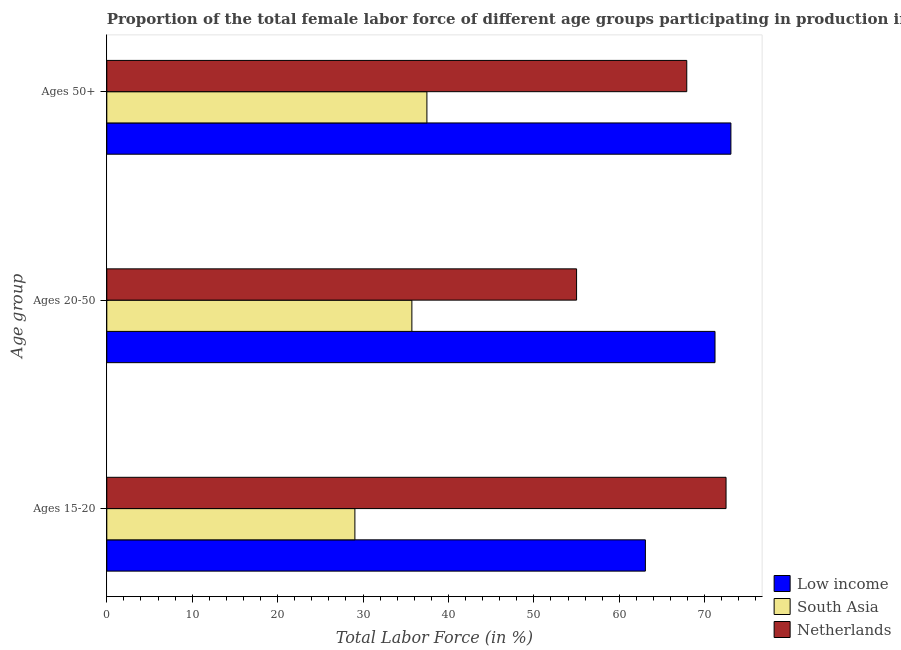How many groups of bars are there?
Ensure brevity in your answer.  3. Are the number of bars per tick equal to the number of legend labels?
Provide a short and direct response. Yes. How many bars are there on the 1st tick from the top?
Keep it short and to the point. 3. How many bars are there on the 2nd tick from the bottom?
Offer a terse response. 3. What is the label of the 2nd group of bars from the top?
Offer a terse response. Ages 20-50. What is the percentage of female labor force within the age group 20-50 in Low income?
Your answer should be very brief. 71.21. Across all countries, what is the maximum percentage of female labor force above age 50?
Give a very brief answer. 73.07. Across all countries, what is the minimum percentage of female labor force within the age group 20-50?
Make the answer very short. 35.72. In which country was the percentage of female labor force above age 50 maximum?
Ensure brevity in your answer.  Low income. In which country was the percentage of female labor force within the age group 20-50 minimum?
Your response must be concise. South Asia. What is the total percentage of female labor force within the age group 15-20 in the graph?
Ensure brevity in your answer.  164.6. What is the difference between the percentage of female labor force within the age group 15-20 in South Asia and that in Netherlands?
Your response must be concise. -43.45. What is the difference between the percentage of female labor force above age 50 in Netherlands and the percentage of female labor force within the age group 15-20 in Low income?
Your response must be concise. 4.84. What is the average percentage of female labor force within the age group 20-50 per country?
Your answer should be compact. 53.98. What is the difference between the percentage of female labor force within the age group 20-50 and percentage of female labor force within the age group 15-20 in South Asia?
Keep it short and to the point. 6.67. In how many countries, is the percentage of female labor force within the age group 20-50 greater than 50 %?
Offer a terse response. 2. What is the ratio of the percentage of female labor force within the age group 20-50 in Low income to that in Netherlands?
Your answer should be very brief. 1.29. Is the percentage of female labor force within the age group 20-50 in South Asia less than that in Low income?
Give a very brief answer. Yes. What is the difference between the highest and the second highest percentage of female labor force within the age group 20-50?
Keep it short and to the point. 16.21. What is the difference between the highest and the lowest percentage of female labor force within the age group 15-20?
Your response must be concise. 43.45. Is the sum of the percentage of female labor force above age 50 in Netherlands and South Asia greater than the maximum percentage of female labor force within the age group 15-20 across all countries?
Your answer should be compact. Yes. What does the 2nd bar from the top in Ages 20-50 represents?
Offer a terse response. South Asia. What does the 1st bar from the bottom in Ages 50+ represents?
Your response must be concise. Low income. Is it the case that in every country, the sum of the percentage of female labor force within the age group 15-20 and percentage of female labor force within the age group 20-50 is greater than the percentage of female labor force above age 50?
Your response must be concise. Yes. How many bars are there?
Give a very brief answer. 9. What is the title of the graph?
Offer a very short reply. Proportion of the total female labor force of different age groups participating in production in 2002. Does "Somalia" appear as one of the legend labels in the graph?
Offer a very short reply. No. What is the label or title of the X-axis?
Make the answer very short. Total Labor Force (in %). What is the label or title of the Y-axis?
Provide a short and direct response. Age group. What is the Total Labor Force (in %) in Low income in Ages 15-20?
Your answer should be very brief. 63.06. What is the Total Labor Force (in %) in South Asia in Ages 15-20?
Give a very brief answer. 29.05. What is the Total Labor Force (in %) in Netherlands in Ages 15-20?
Your response must be concise. 72.5. What is the Total Labor Force (in %) of Low income in Ages 20-50?
Your answer should be compact. 71.21. What is the Total Labor Force (in %) in South Asia in Ages 20-50?
Give a very brief answer. 35.72. What is the Total Labor Force (in %) of Low income in Ages 50+?
Make the answer very short. 73.07. What is the Total Labor Force (in %) in South Asia in Ages 50+?
Your response must be concise. 37.48. What is the Total Labor Force (in %) of Netherlands in Ages 50+?
Your answer should be very brief. 67.9. Across all Age group, what is the maximum Total Labor Force (in %) of Low income?
Keep it short and to the point. 73.07. Across all Age group, what is the maximum Total Labor Force (in %) in South Asia?
Your answer should be very brief. 37.48. Across all Age group, what is the maximum Total Labor Force (in %) of Netherlands?
Offer a very short reply. 72.5. Across all Age group, what is the minimum Total Labor Force (in %) of Low income?
Offer a very short reply. 63.06. Across all Age group, what is the minimum Total Labor Force (in %) of South Asia?
Provide a succinct answer. 29.05. Across all Age group, what is the minimum Total Labor Force (in %) of Netherlands?
Your answer should be compact. 55. What is the total Total Labor Force (in %) in Low income in the graph?
Ensure brevity in your answer.  207.33. What is the total Total Labor Force (in %) of South Asia in the graph?
Give a very brief answer. 102.24. What is the total Total Labor Force (in %) in Netherlands in the graph?
Ensure brevity in your answer.  195.4. What is the difference between the Total Labor Force (in %) of Low income in Ages 15-20 and that in Ages 20-50?
Make the answer very short. -8.15. What is the difference between the Total Labor Force (in %) in South Asia in Ages 15-20 and that in Ages 20-50?
Offer a very short reply. -6.67. What is the difference between the Total Labor Force (in %) in Low income in Ages 15-20 and that in Ages 50+?
Your response must be concise. -10.01. What is the difference between the Total Labor Force (in %) in South Asia in Ages 15-20 and that in Ages 50+?
Offer a very short reply. -8.43. What is the difference between the Total Labor Force (in %) in Netherlands in Ages 15-20 and that in Ages 50+?
Ensure brevity in your answer.  4.6. What is the difference between the Total Labor Force (in %) of Low income in Ages 20-50 and that in Ages 50+?
Offer a terse response. -1.86. What is the difference between the Total Labor Force (in %) of South Asia in Ages 20-50 and that in Ages 50+?
Your response must be concise. -1.76. What is the difference between the Total Labor Force (in %) of Low income in Ages 15-20 and the Total Labor Force (in %) of South Asia in Ages 20-50?
Offer a terse response. 27.34. What is the difference between the Total Labor Force (in %) in Low income in Ages 15-20 and the Total Labor Force (in %) in Netherlands in Ages 20-50?
Offer a very short reply. 8.06. What is the difference between the Total Labor Force (in %) of South Asia in Ages 15-20 and the Total Labor Force (in %) of Netherlands in Ages 20-50?
Give a very brief answer. -25.95. What is the difference between the Total Labor Force (in %) of Low income in Ages 15-20 and the Total Labor Force (in %) of South Asia in Ages 50+?
Offer a terse response. 25.58. What is the difference between the Total Labor Force (in %) of Low income in Ages 15-20 and the Total Labor Force (in %) of Netherlands in Ages 50+?
Your response must be concise. -4.84. What is the difference between the Total Labor Force (in %) in South Asia in Ages 15-20 and the Total Labor Force (in %) in Netherlands in Ages 50+?
Make the answer very short. -38.85. What is the difference between the Total Labor Force (in %) of Low income in Ages 20-50 and the Total Labor Force (in %) of South Asia in Ages 50+?
Offer a very short reply. 33.73. What is the difference between the Total Labor Force (in %) in Low income in Ages 20-50 and the Total Labor Force (in %) in Netherlands in Ages 50+?
Your answer should be very brief. 3.31. What is the difference between the Total Labor Force (in %) in South Asia in Ages 20-50 and the Total Labor Force (in %) in Netherlands in Ages 50+?
Provide a short and direct response. -32.18. What is the average Total Labor Force (in %) in Low income per Age group?
Offer a terse response. 69.11. What is the average Total Labor Force (in %) of South Asia per Age group?
Your response must be concise. 34.08. What is the average Total Labor Force (in %) of Netherlands per Age group?
Keep it short and to the point. 65.13. What is the difference between the Total Labor Force (in %) of Low income and Total Labor Force (in %) of South Asia in Ages 15-20?
Your response must be concise. 34.01. What is the difference between the Total Labor Force (in %) in Low income and Total Labor Force (in %) in Netherlands in Ages 15-20?
Provide a short and direct response. -9.44. What is the difference between the Total Labor Force (in %) in South Asia and Total Labor Force (in %) in Netherlands in Ages 15-20?
Provide a short and direct response. -43.45. What is the difference between the Total Labor Force (in %) of Low income and Total Labor Force (in %) of South Asia in Ages 20-50?
Your response must be concise. 35.49. What is the difference between the Total Labor Force (in %) in Low income and Total Labor Force (in %) in Netherlands in Ages 20-50?
Keep it short and to the point. 16.21. What is the difference between the Total Labor Force (in %) in South Asia and Total Labor Force (in %) in Netherlands in Ages 20-50?
Keep it short and to the point. -19.28. What is the difference between the Total Labor Force (in %) in Low income and Total Labor Force (in %) in South Asia in Ages 50+?
Your response must be concise. 35.59. What is the difference between the Total Labor Force (in %) in Low income and Total Labor Force (in %) in Netherlands in Ages 50+?
Keep it short and to the point. 5.17. What is the difference between the Total Labor Force (in %) in South Asia and Total Labor Force (in %) in Netherlands in Ages 50+?
Your answer should be very brief. -30.42. What is the ratio of the Total Labor Force (in %) of Low income in Ages 15-20 to that in Ages 20-50?
Give a very brief answer. 0.89. What is the ratio of the Total Labor Force (in %) of South Asia in Ages 15-20 to that in Ages 20-50?
Make the answer very short. 0.81. What is the ratio of the Total Labor Force (in %) of Netherlands in Ages 15-20 to that in Ages 20-50?
Keep it short and to the point. 1.32. What is the ratio of the Total Labor Force (in %) in Low income in Ages 15-20 to that in Ages 50+?
Your response must be concise. 0.86. What is the ratio of the Total Labor Force (in %) of South Asia in Ages 15-20 to that in Ages 50+?
Offer a very short reply. 0.78. What is the ratio of the Total Labor Force (in %) of Netherlands in Ages 15-20 to that in Ages 50+?
Give a very brief answer. 1.07. What is the ratio of the Total Labor Force (in %) in Low income in Ages 20-50 to that in Ages 50+?
Give a very brief answer. 0.97. What is the ratio of the Total Labor Force (in %) in South Asia in Ages 20-50 to that in Ages 50+?
Offer a very short reply. 0.95. What is the ratio of the Total Labor Force (in %) in Netherlands in Ages 20-50 to that in Ages 50+?
Your response must be concise. 0.81. What is the difference between the highest and the second highest Total Labor Force (in %) in Low income?
Provide a short and direct response. 1.86. What is the difference between the highest and the second highest Total Labor Force (in %) of South Asia?
Keep it short and to the point. 1.76. What is the difference between the highest and the lowest Total Labor Force (in %) of Low income?
Your answer should be compact. 10.01. What is the difference between the highest and the lowest Total Labor Force (in %) of South Asia?
Provide a succinct answer. 8.43. 